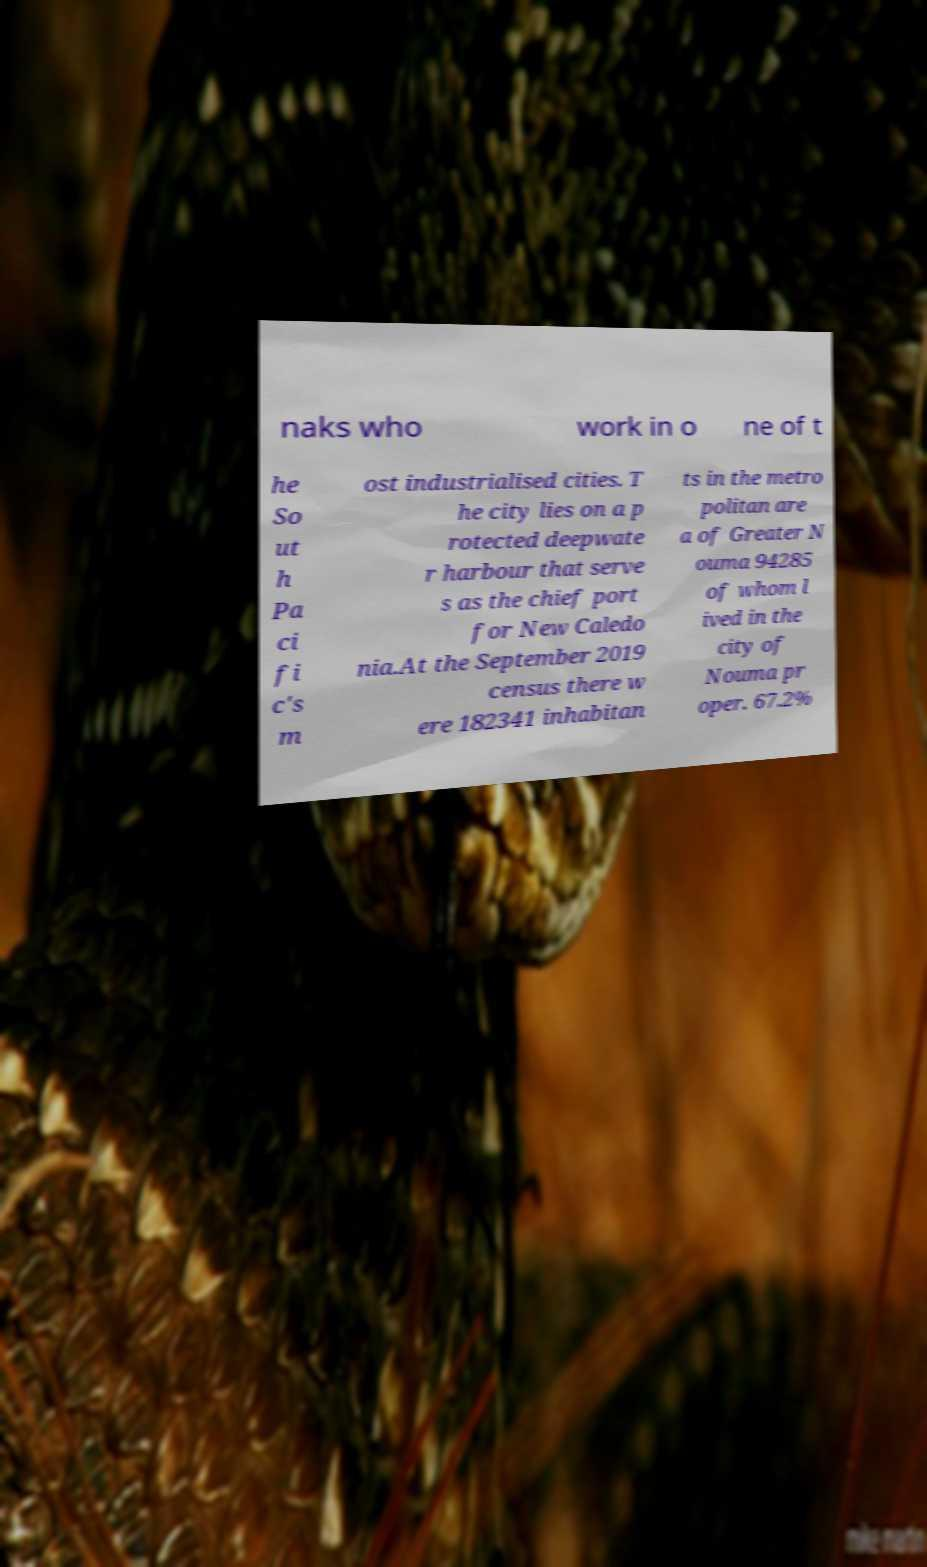Can you accurately transcribe the text from the provided image for me? naks who work in o ne of t he So ut h Pa ci fi c's m ost industrialised cities. T he city lies on a p rotected deepwate r harbour that serve s as the chief port for New Caledo nia.At the September 2019 census there w ere 182341 inhabitan ts in the metro politan are a of Greater N ouma 94285 of whom l ived in the city of Nouma pr oper. 67.2% 